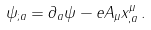<formula> <loc_0><loc_0><loc_500><loc_500>\psi _ { ; a } = \partial _ { a } \psi - e A _ { \mu } x ^ { \mu } _ { , a } \, .</formula> 